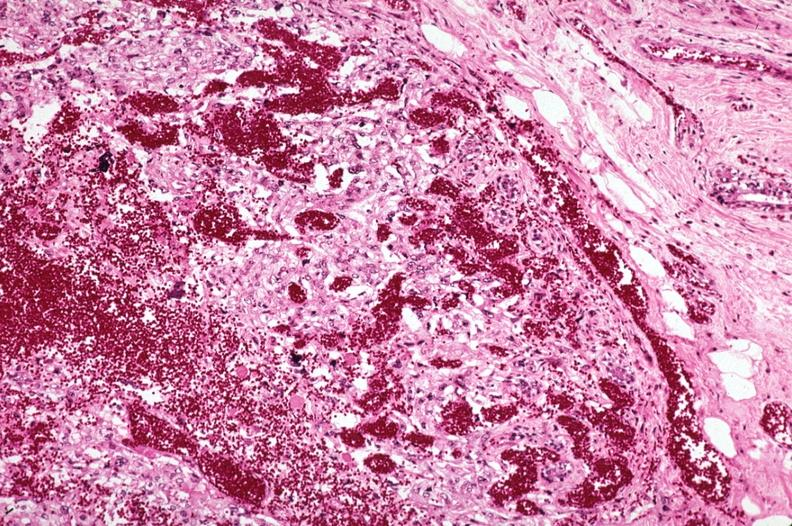s breast present?
Answer the question using a single word or phrase. Yes 